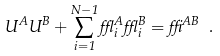<formula> <loc_0><loc_0><loc_500><loc_500>U ^ { A } U ^ { B } + \sum _ { i = 1 } ^ { N - 1 } \epsilon ^ { A } _ { i } \epsilon ^ { B } _ { i } = \delta ^ { A B } \ .</formula> 